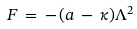<formula> <loc_0><loc_0><loc_500><loc_500>F \, = \, - \, ( a \, - \, \kappa ) \Lambda ^ { 2 }</formula> 